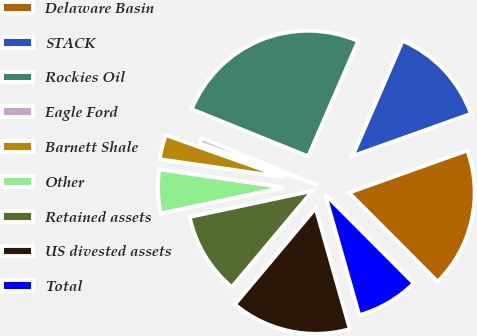Convert chart to OTSL. <chart><loc_0><loc_0><loc_500><loc_500><pie_chart><fcel>Delaware Basin<fcel>STACK<fcel>Rockies Oil<fcel>Eagle Ford<fcel>Barnett Shale<fcel>Other<fcel>Retained assets<fcel>US divested assets<fcel>Total<nl><fcel>17.98%<fcel>13.03%<fcel>25.39%<fcel>0.68%<fcel>3.15%<fcel>5.62%<fcel>10.56%<fcel>15.5%<fcel>8.09%<nl></chart> 